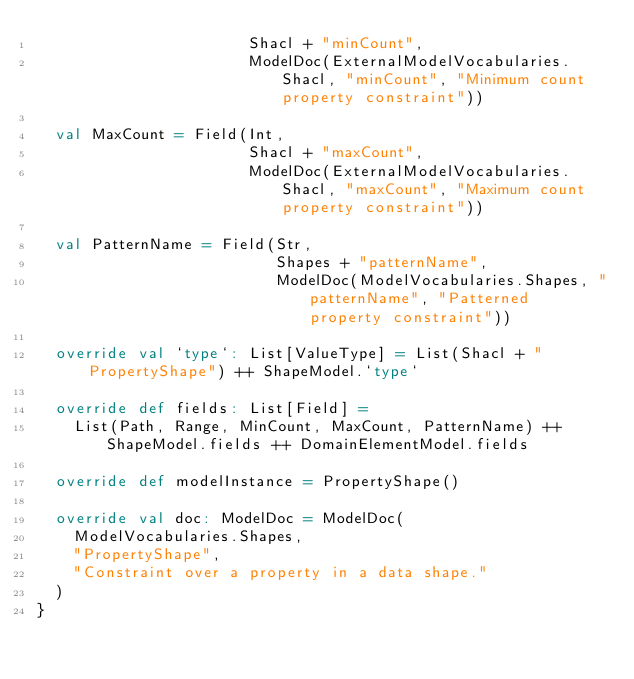<code> <loc_0><loc_0><loc_500><loc_500><_Scala_>                       Shacl + "minCount",
                       ModelDoc(ExternalModelVocabularies.Shacl, "minCount", "Minimum count property constraint"))

  val MaxCount = Field(Int,
                       Shacl + "maxCount",
                       ModelDoc(ExternalModelVocabularies.Shacl, "maxCount", "Maximum count property constraint"))

  val PatternName = Field(Str,
                          Shapes + "patternName",
                          ModelDoc(ModelVocabularies.Shapes, "patternName", "Patterned property constraint"))

  override val `type`: List[ValueType] = List(Shacl + "PropertyShape") ++ ShapeModel.`type`

  override def fields: List[Field] =
    List(Path, Range, MinCount, MaxCount, PatternName) ++ ShapeModel.fields ++ DomainElementModel.fields

  override def modelInstance = PropertyShape()

  override val doc: ModelDoc = ModelDoc(
    ModelVocabularies.Shapes,
    "PropertyShape",
    "Constraint over a property in a data shape."
  )
}
</code> 